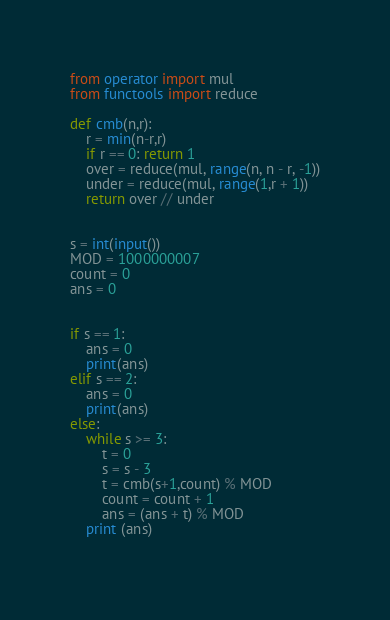Convert code to text. <code><loc_0><loc_0><loc_500><loc_500><_Python_>from operator import mul
from functools import reduce

def cmb(n,r):
    r = min(n-r,r)
    if r == 0: return 1
    over = reduce(mul, range(n, n - r, -1))
    under = reduce(mul, range(1,r + 1))
    return over // under


s = int(input())
MOD = 1000000007
count = 0
ans = 0


if s == 1:
	ans = 0
	print(ans)
elif s == 2:
	ans = 0
	print(ans)
else:
	while s >= 3:
		t = 0
		s = s - 3
		t = cmb(s+1,count) % MOD
		count = count + 1
		ans = (ans + t) % MOD
	print (ans)
              </code> 